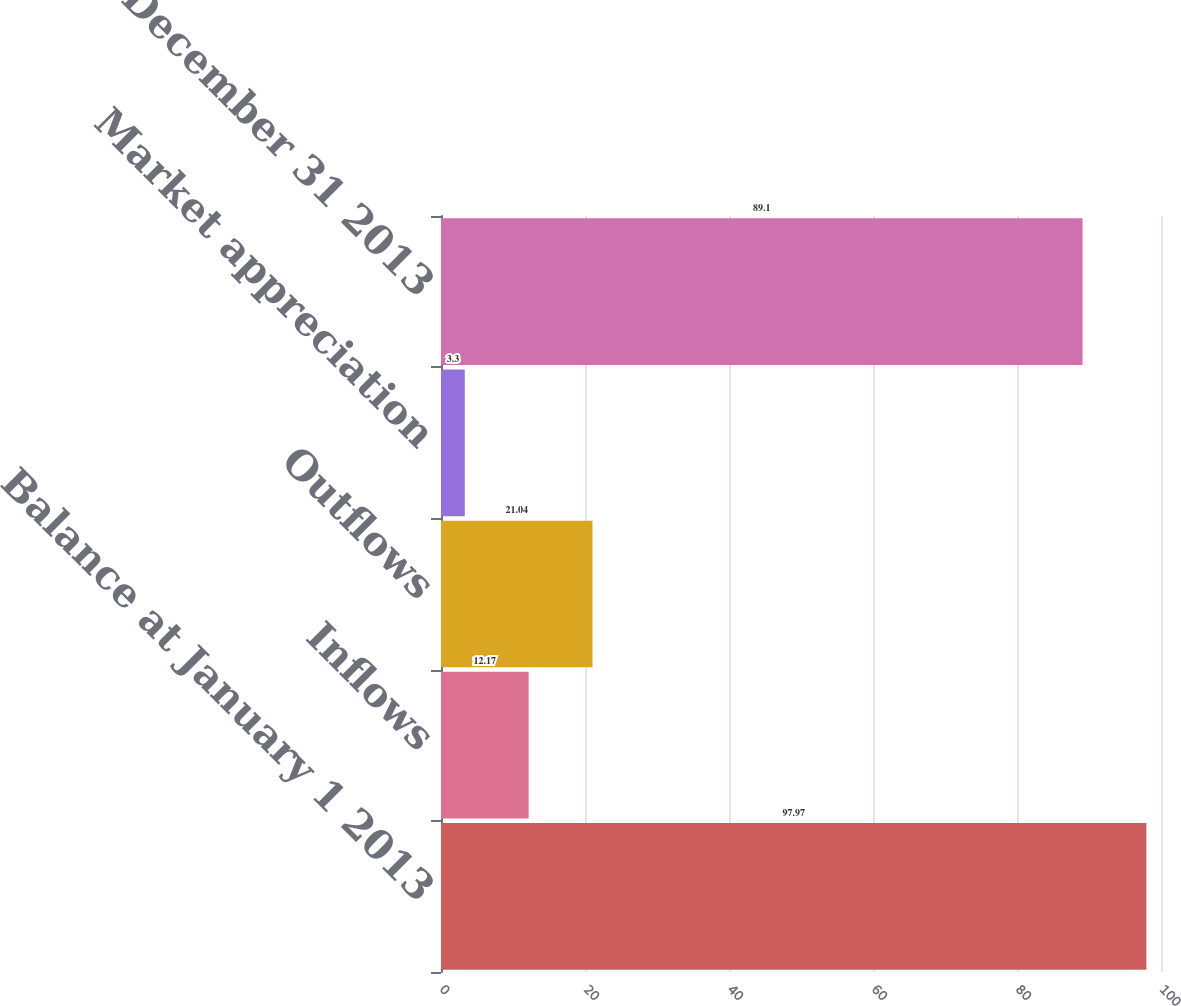<chart> <loc_0><loc_0><loc_500><loc_500><bar_chart><fcel>Balance at January 1 2013<fcel>Inflows<fcel>Outflows<fcel>Market appreciation<fcel>Balance at December 31 2013<nl><fcel>97.97<fcel>12.17<fcel>21.04<fcel>3.3<fcel>89.1<nl></chart> 